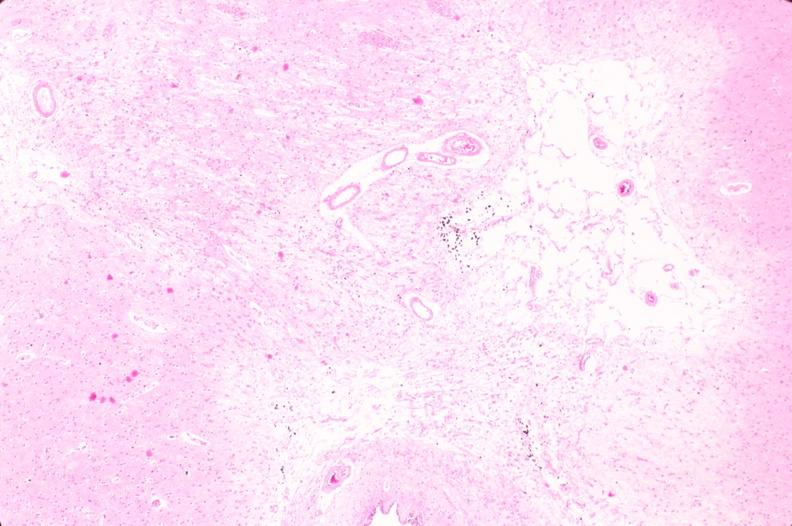what does this image show?
Answer the question using a single word or phrase. Brain 